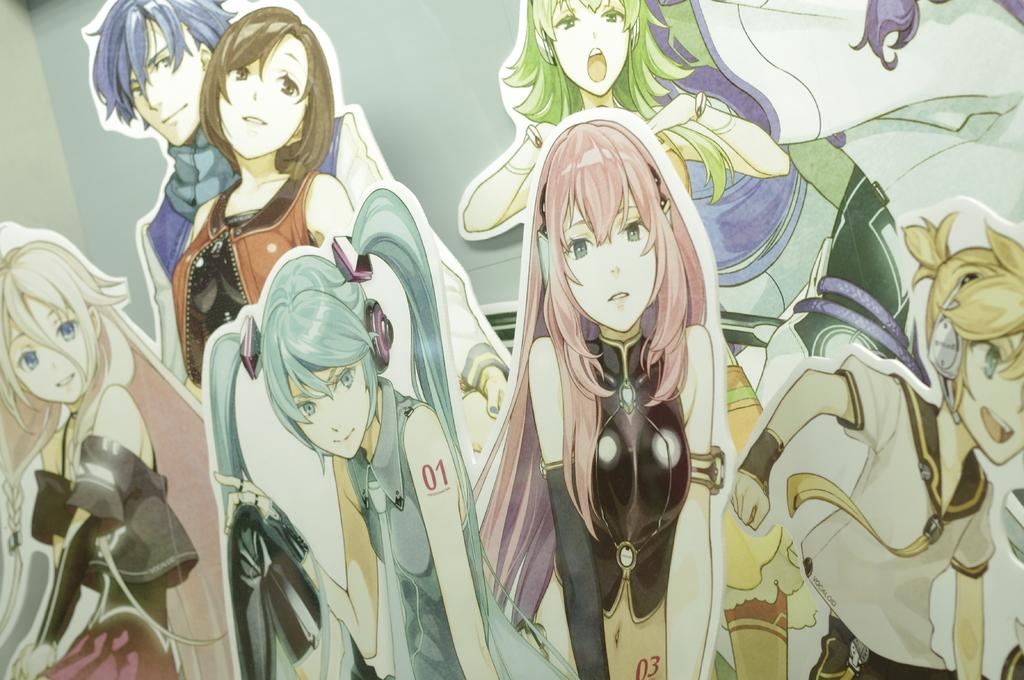What type of image is being described? The image is an animated image. What kind of characters can be seen in the image? There are cartoon characters in the image. What type of sofa is visible in the image? There is no sofa present in the image, as it is an animated image featuring cartoon characters. 